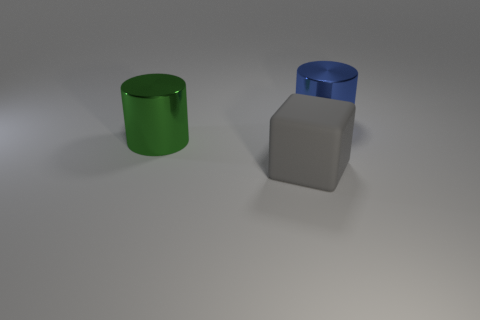Are there more big yellow rubber balls than large green objects?
Offer a very short reply. No. Is there a blue metal object that is behind the cylinder to the right of the big object that is left of the gray thing?
Provide a succinct answer. No. How many other objects are there of the same size as the gray object?
Provide a succinct answer. 2. There is a large blue thing; are there any green shiny things to the left of it?
Your answer should be compact. Yes. Does the matte block have the same color as the metallic thing in front of the blue metal object?
Provide a short and direct response. No. There is a thing behind the shiny thing that is left of the blue object on the right side of the block; what is its color?
Your answer should be very brief. Blue. Is there another large object of the same shape as the large green thing?
Give a very brief answer. Yes. What color is the shiny cylinder that is the same size as the green shiny object?
Offer a terse response. Blue. What is the cylinder on the right side of the large green thing made of?
Offer a terse response. Metal. Does the green thing that is behind the gray cube have the same shape as the metallic thing that is to the right of the big gray rubber block?
Offer a very short reply. Yes. 